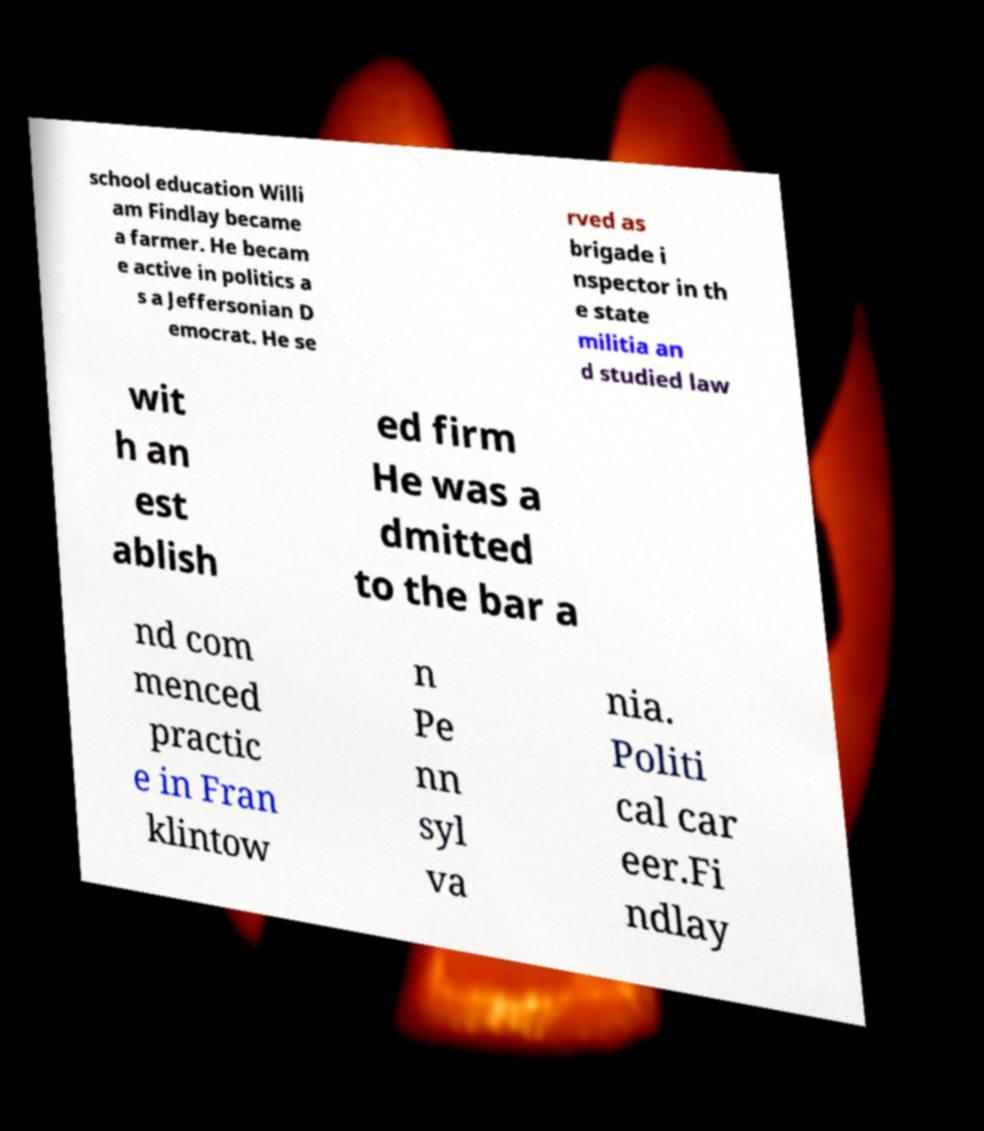What messages or text are displayed in this image? I need them in a readable, typed format. school education Willi am Findlay became a farmer. He becam e active in politics a s a Jeffersonian D emocrat. He se rved as brigade i nspector in th e state militia an d studied law wit h an est ablish ed firm He was a dmitted to the bar a nd com menced practic e in Fran klintow n Pe nn syl va nia. Politi cal car eer.Fi ndlay 